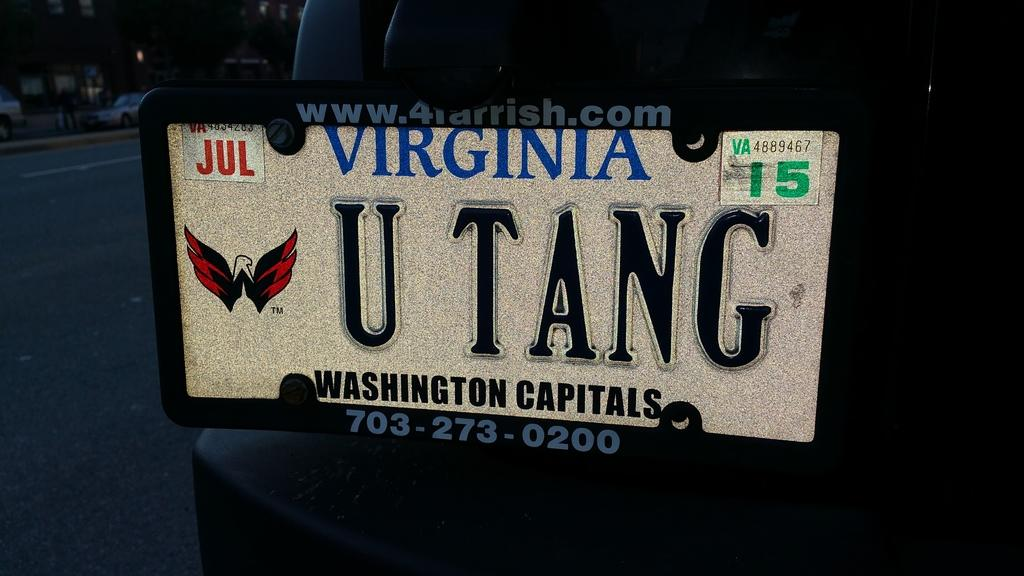Provide a one-sentence caption for the provided image. Virginia license vanity license plate displaying U TANG. 